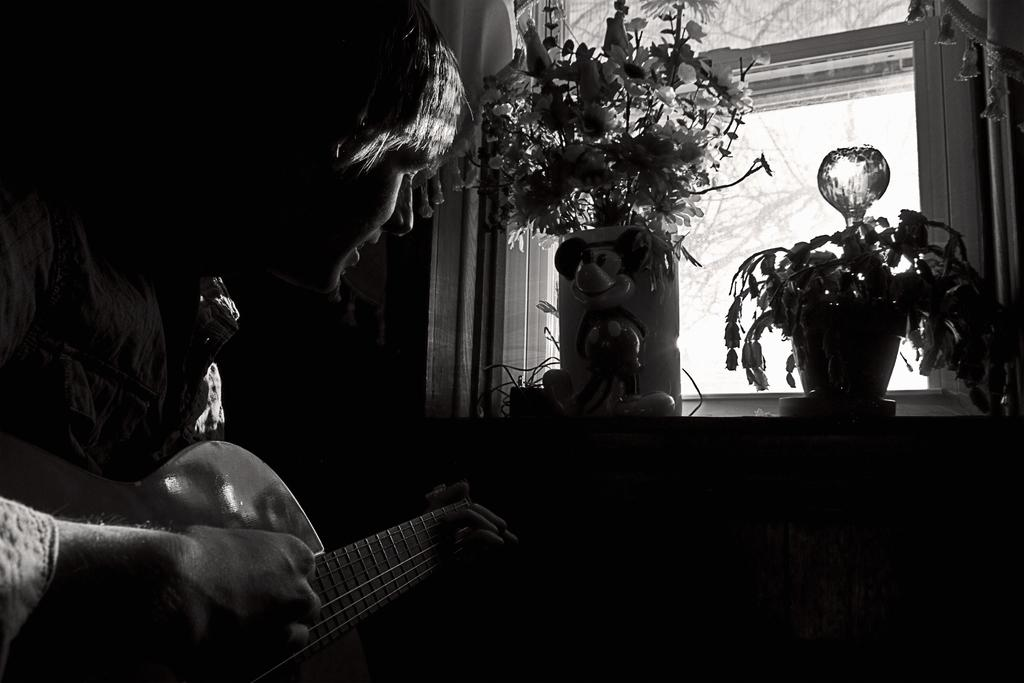What is the color scheme of the image? The image is black and white. Who is present in the image? There is a man in the image. What is the man doing in the image? The man is playing a guitar. What can be seen in the background of the image? There is a window in the image. What is located near the window in the image? There are two small plants in front of the window. How many flowers are growing on the plants in the image? There are no flowers visible on the plants in the image; they are small plants without any flowers. 